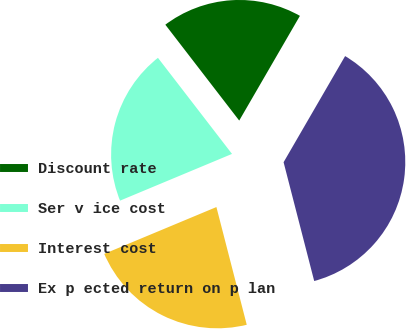Convert chart. <chart><loc_0><loc_0><loc_500><loc_500><pie_chart><fcel>Discount rate<fcel>Ser v ice cost<fcel>Interest cost<fcel>Ex p ected return on p lan<nl><fcel>18.81%<fcel>20.84%<fcel>22.72%<fcel>37.62%<nl></chart> 